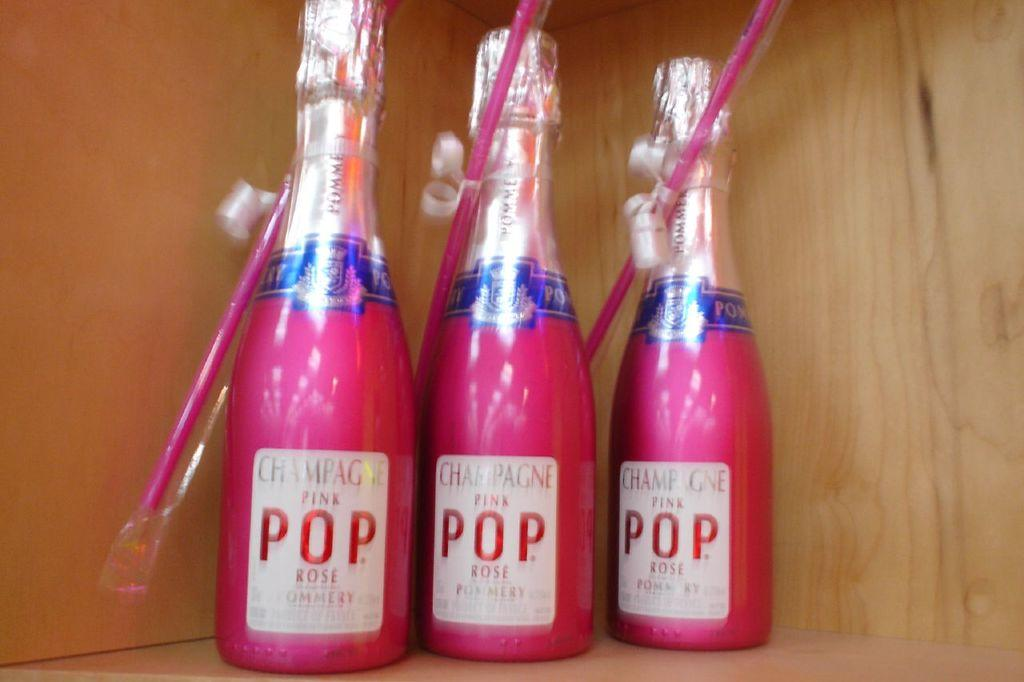<image>
Give a short and clear explanation of the subsequent image. Three pink bottles that say POP on the label. 